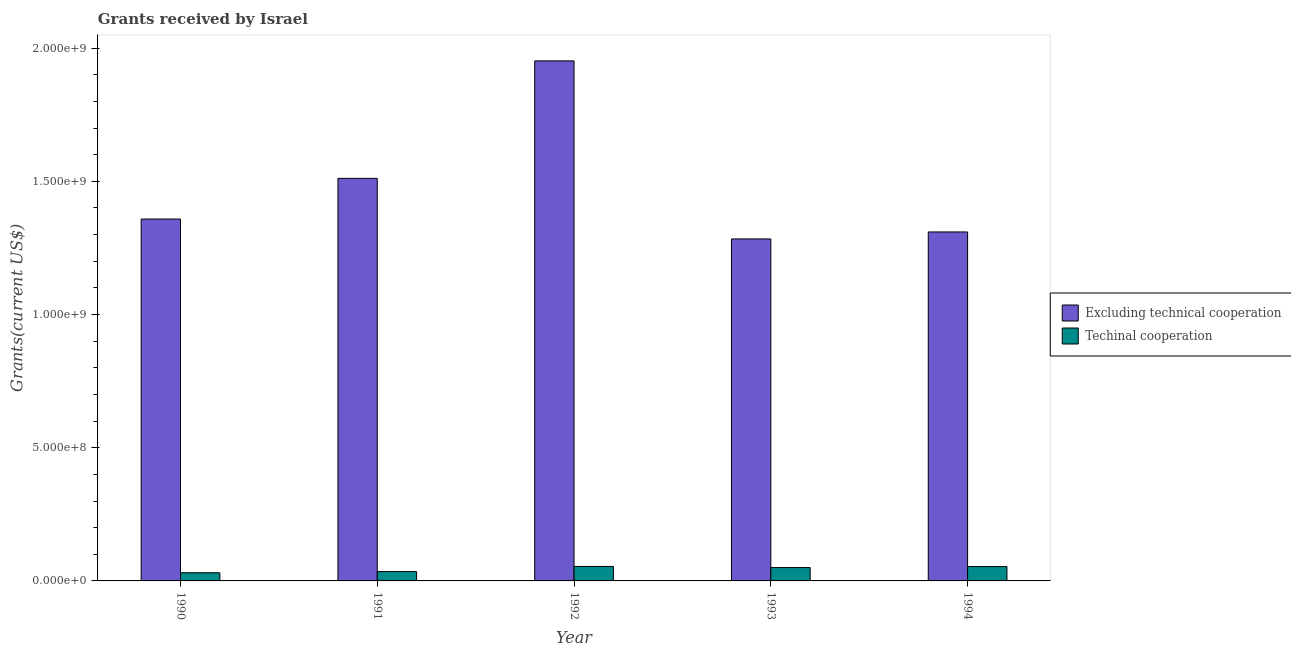How many different coloured bars are there?
Your answer should be very brief. 2. How many bars are there on the 5th tick from the left?
Provide a succinct answer. 2. How many bars are there on the 3rd tick from the right?
Give a very brief answer. 2. In how many cases, is the number of bars for a given year not equal to the number of legend labels?
Your answer should be very brief. 0. What is the amount of grants received(excluding technical cooperation) in 1990?
Ensure brevity in your answer.  1.36e+09. Across all years, what is the maximum amount of grants received(including technical cooperation)?
Ensure brevity in your answer.  5.44e+07. Across all years, what is the minimum amount of grants received(including technical cooperation)?
Ensure brevity in your answer.  3.07e+07. In which year was the amount of grants received(including technical cooperation) maximum?
Make the answer very short. 1992. What is the total amount of grants received(excluding technical cooperation) in the graph?
Keep it short and to the point. 7.42e+09. What is the difference between the amount of grants received(excluding technical cooperation) in 1992 and that in 1994?
Your response must be concise. 6.42e+08. What is the difference between the amount of grants received(including technical cooperation) in 1991 and the amount of grants received(excluding technical cooperation) in 1992?
Provide a short and direct response. -1.93e+07. What is the average amount of grants received(including technical cooperation) per year?
Make the answer very short. 4.48e+07. In how many years, is the amount of grants received(excluding technical cooperation) greater than 1400000000 US$?
Make the answer very short. 2. What is the ratio of the amount of grants received(excluding technical cooperation) in 1991 to that in 1993?
Your answer should be very brief. 1.18. Is the amount of grants received(including technical cooperation) in 1991 less than that in 1992?
Provide a short and direct response. Yes. What is the difference between the highest and the second highest amount of grants received(excluding technical cooperation)?
Give a very brief answer. 4.41e+08. What is the difference between the highest and the lowest amount of grants received(excluding technical cooperation)?
Give a very brief answer. 6.68e+08. What does the 1st bar from the left in 1990 represents?
Provide a succinct answer. Excluding technical cooperation. What does the 2nd bar from the right in 1991 represents?
Ensure brevity in your answer.  Excluding technical cooperation. How many bars are there?
Ensure brevity in your answer.  10. How many years are there in the graph?
Keep it short and to the point. 5. What is the difference between two consecutive major ticks on the Y-axis?
Make the answer very short. 5.00e+08. What is the title of the graph?
Your answer should be very brief. Grants received by Israel. Does "Fraud firms" appear as one of the legend labels in the graph?
Give a very brief answer. No. What is the label or title of the X-axis?
Offer a very short reply. Year. What is the label or title of the Y-axis?
Provide a short and direct response. Grants(current US$). What is the Grants(current US$) of Excluding technical cooperation in 1990?
Your answer should be very brief. 1.36e+09. What is the Grants(current US$) in Techinal cooperation in 1990?
Keep it short and to the point. 3.07e+07. What is the Grants(current US$) of Excluding technical cooperation in 1991?
Your response must be concise. 1.51e+09. What is the Grants(current US$) in Techinal cooperation in 1991?
Keep it short and to the point. 3.51e+07. What is the Grants(current US$) in Excluding technical cooperation in 1992?
Your answer should be compact. 1.95e+09. What is the Grants(current US$) of Techinal cooperation in 1992?
Offer a terse response. 5.44e+07. What is the Grants(current US$) of Excluding technical cooperation in 1993?
Make the answer very short. 1.28e+09. What is the Grants(current US$) in Techinal cooperation in 1993?
Ensure brevity in your answer.  5.01e+07. What is the Grants(current US$) of Excluding technical cooperation in 1994?
Your response must be concise. 1.31e+09. What is the Grants(current US$) of Techinal cooperation in 1994?
Provide a short and direct response. 5.39e+07. Across all years, what is the maximum Grants(current US$) of Excluding technical cooperation?
Offer a very short reply. 1.95e+09. Across all years, what is the maximum Grants(current US$) of Techinal cooperation?
Offer a terse response. 5.44e+07. Across all years, what is the minimum Grants(current US$) in Excluding technical cooperation?
Offer a terse response. 1.28e+09. Across all years, what is the minimum Grants(current US$) of Techinal cooperation?
Your answer should be very brief. 3.07e+07. What is the total Grants(current US$) of Excluding technical cooperation in the graph?
Your answer should be compact. 7.42e+09. What is the total Grants(current US$) of Techinal cooperation in the graph?
Keep it short and to the point. 2.24e+08. What is the difference between the Grants(current US$) of Excluding technical cooperation in 1990 and that in 1991?
Give a very brief answer. -1.53e+08. What is the difference between the Grants(current US$) in Techinal cooperation in 1990 and that in 1991?
Give a very brief answer. -4.36e+06. What is the difference between the Grants(current US$) of Excluding technical cooperation in 1990 and that in 1992?
Your response must be concise. -5.94e+08. What is the difference between the Grants(current US$) in Techinal cooperation in 1990 and that in 1992?
Provide a short and direct response. -2.36e+07. What is the difference between the Grants(current US$) in Excluding technical cooperation in 1990 and that in 1993?
Provide a succinct answer. 7.47e+07. What is the difference between the Grants(current US$) in Techinal cooperation in 1990 and that in 1993?
Your response must be concise. -1.94e+07. What is the difference between the Grants(current US$) of Excluding technical cooperation in 1990 and that in 1994?
Keep it short and to the point. 4.84e+07. What is the difference between the Grants(current US$) in Techinal cooperation in 1990 and that in 1994?
Offer a terse response. -2.32e+07. What is the difference between the Grants(current US$) in Excluding technical cooperation in 1991 and that in 1992?
Make the answer very short. -4.41e+08. What is the difference between the Grants(current US$) in Techinal cooperation in 1991 and that in 1992?
Keep it short and to the point. -1.93e+07. What is the difference between the Grants(current US$) in Excluding technical cooperation in 1991 and that in 1993?
Offer a terse response. 2.27e+08. What is the difference between the Grants(current US$) in Techinal cooperation in 1991 and that in 1993?
Give a very brief answer. -1.50e+07. What is the difference between the Grants(current US$) in Excluding technical cooperation in 1991 and that in 1994?
Make the answer very short. 2.01e+08. What is the difference between the Grants(current US$) in Techinal cooperation in 1991 and that in 1994?
Offer a very short reply. -1.88e+07. What is the difference between the Grants(current US$) of Excluding technical cooperation in 1992 and that in 1993?
Ensure brevity in your answer.  6.68e+08. What is the difference between the Grants(current US$) in Techinal cooperation in 1992 and that in 1993?
Keep it short and to the point. 4.24e+06. What is the difference between the Grants(current US$) of Excluding technical cooperation in 1992 and that in 1994?
Your response must be concise. 6.42e+08. What is the difference between the Grants(current US$) of Techinal cooperation in 1992 and that in 1994?
Offer a very short reply. 4.60e+05. What is the difference between the Grants(current US$) in Excluding technical cooperation in 1993 and that in 1994?
Keep it short and to the point. -2.63e+07. What is the difference between the Grants(current US$) of Techinal cooperation in 1993 and that in 1994?
Offer a terse response. -3.78e+06. What is the difference between the Grants(current US$) in Excluding technical cooperation in 1990 and the Grants(current US$) in Techinal cooperation in 1991?
Your response must be concise. 1.32e+09. What is the difference between the Grants(current US$) in Excluding technical cooperation in 1990 and the Grants(current US$) in Techinal cooperation in 1992?
Provide a succinct answer. 1.30e+09. What is the difference between the Grants(current US$) in Excluding technical cooperation in 1990 and the Grants(current US$) in Techinal cooperation in 1993?
Provide a succinct answer. 1.31e+09. What is the difference between the Grants(current US$) of Excluding technical cooperation in 1990 and the Grants(current US$) of Techinal cooperation in 1994?
Your response must be concise. 1.30e+09. What is the difference between the Grants(current US$) in Excluding technical cooperation in 1991 and the Grants(current US$) in Techinal cooperation in 1992?
Offer a very short reply. 1.46e+09. What is the difference between the Grants(current US$) in Excluding technical cooperation in 1991 and the Grants(current US$) in Techinal cooperation in 1993?
Offer a terse response. 1.46e+09. What is the difference between the Grants(current US$) in Excluding technical cooperation in 1991 and the Grants(current US$) in Techinal cooperation in 1994?
Your answer should be very brief. 1.46e+09. What is the difference between the Grants(current US$) in Excluding technical cooperation in 1992 and the Grants(current US$) in Techinal cooperation in 1993?
Offer a very short reply. 1.90e+09. What is the difference between the Grants(current US$) in Excluding technical cooperation in 1992 and the Grants(current US$) in Techinal cooperation in 1994?
Your response must be concise. 1.90e+09. What is the difference between the Grants(current US$) of Excluding technical cooperation in 1993 and the Grants(current US$) of Techinal cooperation in 1994?
Keep it short and to the point. 1.23e+09. What is the average Grants(current US$) of Excluding technical cooperation per year?
Provide a short and direct response. 1.48e+09. What is the average Grants(current US$) of Techinal cooperation per year?
Keep it short and to the point. 4.48e+07. In the year 1990, what is the difference between the Grants(current US$) of Excluding technical cooperation and Grants(current US$) of Techinal cooperation?
Give a very brief answer. 1.33e+09. In the year 1991, what is the difference between the Grants(current US$) of Excluding technical cooperation and Grants(current US$) of Techinal cooperation?
Make the answer very short. 1.48e+09. In the year 1992, what is the difference between the Grants(current US$) in Excluding technical cooperation and Grants(current US$) in Techinal cooperation?
Your answer should be compact. 1.90e+09. In the year 1993, what is the difference between the Grants(current US$) in Excluding technical cooperation and Grants(current US$) in Techinal cooperation?
Your response must be concise. 1.23e+09. In the year 1994, what is the difference between the Grants(current US$) of Excluding technical cooperation and Grants(current US$) of Techinal cooperation?
Your response must be concise. 1.26e+09. What is the ratio of the Grants(current US$) in Excluding technical cooperation in 1990 to that in 1991?
Offer a terse response. 0.9. What is the ratio of the Grants(current US$) of Techinal cooperation in 1990 to that in 1991?
Your response must be concise. 0.88. What is the ratio of the Grants(current US$) in Excluding technical cooperation in 1990 to that in 1992?
Your answer should be very brief. 0.7. What is the ratio of the Grants(current US$) of Techinal cooperation in 1990 to that in 1992?
Ensure brevity in your answer.  0.57. What is the ratio of the Grants(current US$) in Excluding technical cooperation in 1990 to that in 1993?
Provide a short and direct response. 1.06. What is the ratio of the Grants(current US$) of Techinal cooperation in 1990 to that in 1993?
Provide a short and direct response. 0.61. What is the ratio of the Grants(current US$) of Excluding technical cooperation in 1990 to that in 1994?
Keep it short and to the point. 1.04. What is the ratio of the Grants(current US$) in Techinal cooperation in 1990 to that in 1994?
Ensure brevity in your answer.  0.57. What is the ratio of the Grants(current US$) of Excluding technical cooperation in 1991 to that in 1992?
Provide a succinct answer. 0.77. What is the ratio of the Grants(current US$) in Techinal cooperation in 1991 to that in 1992?
Your response must be concise. 0.65. What is the ratio of the Grants(current US$) in Excluding technical cooperation in 1991 to that in 1993?
Your response must be concise. 1.18. What is the ratio of the Grants(current US$) of Techinal cooperation in 1991 to that in 1993?
Your answer should be very brief. 0.7. What is the ratio of the Grants(current US$) of Excluding technical cooperation in 1991 to that in 1994?
Offer a terse response. 1.15. What is the ratio of the Grants(current US$) in Techinal cooperation in 1991 to that in 1994?
Offer a very short reply. 0.65. What is the ratio of the Grants(current US$) in Excluding technical cooperation in 1992 to that in 1993?
Provide a short and direct response. 1.52. What is the ratio of the Grants(current US$) of Techinal cooperation in 1992 to that in 1993?
Make the answer very short. 1.08. What is the ratio of the Grants(current US$) of Excluding technical cooperation in 1992 to that in 1994?
Ensure brevity in your answer.  1.49. What is the ratio of the Grants(current US$) in Techinal cooperation in 1992 to that in 1994?
Keep it short and to the point. 1.01. What is the ratio of the Grants(current US$) of Excluding technical cooperation in 1993 to that in 1994?
Your answer should be compact. 0.98. What is the ratio of the Grants(current US$) in Techinal cooperation in 1993 to that in 1994?
Provide a short and direct response. 0.93. What is the difference between the highest and the second highest Grants(current US$) of Excluding technical cooperation?
Provide a short and direct response. 4.41e+08. What is the difference between the highest and the second highest Grants(current US$) of Techinal cooperation?
Offer a very short reply. 4.60e+05. What is the difference between the highest and the lowest Grants(current US$) in Excluding technical cooperation?
Offer a terse response. 6.68e+08. What is the difference between the highest and the lowest Grants(current US$) of Techinal cooperation?
Provide a succinct answer. 2.36e+07. 